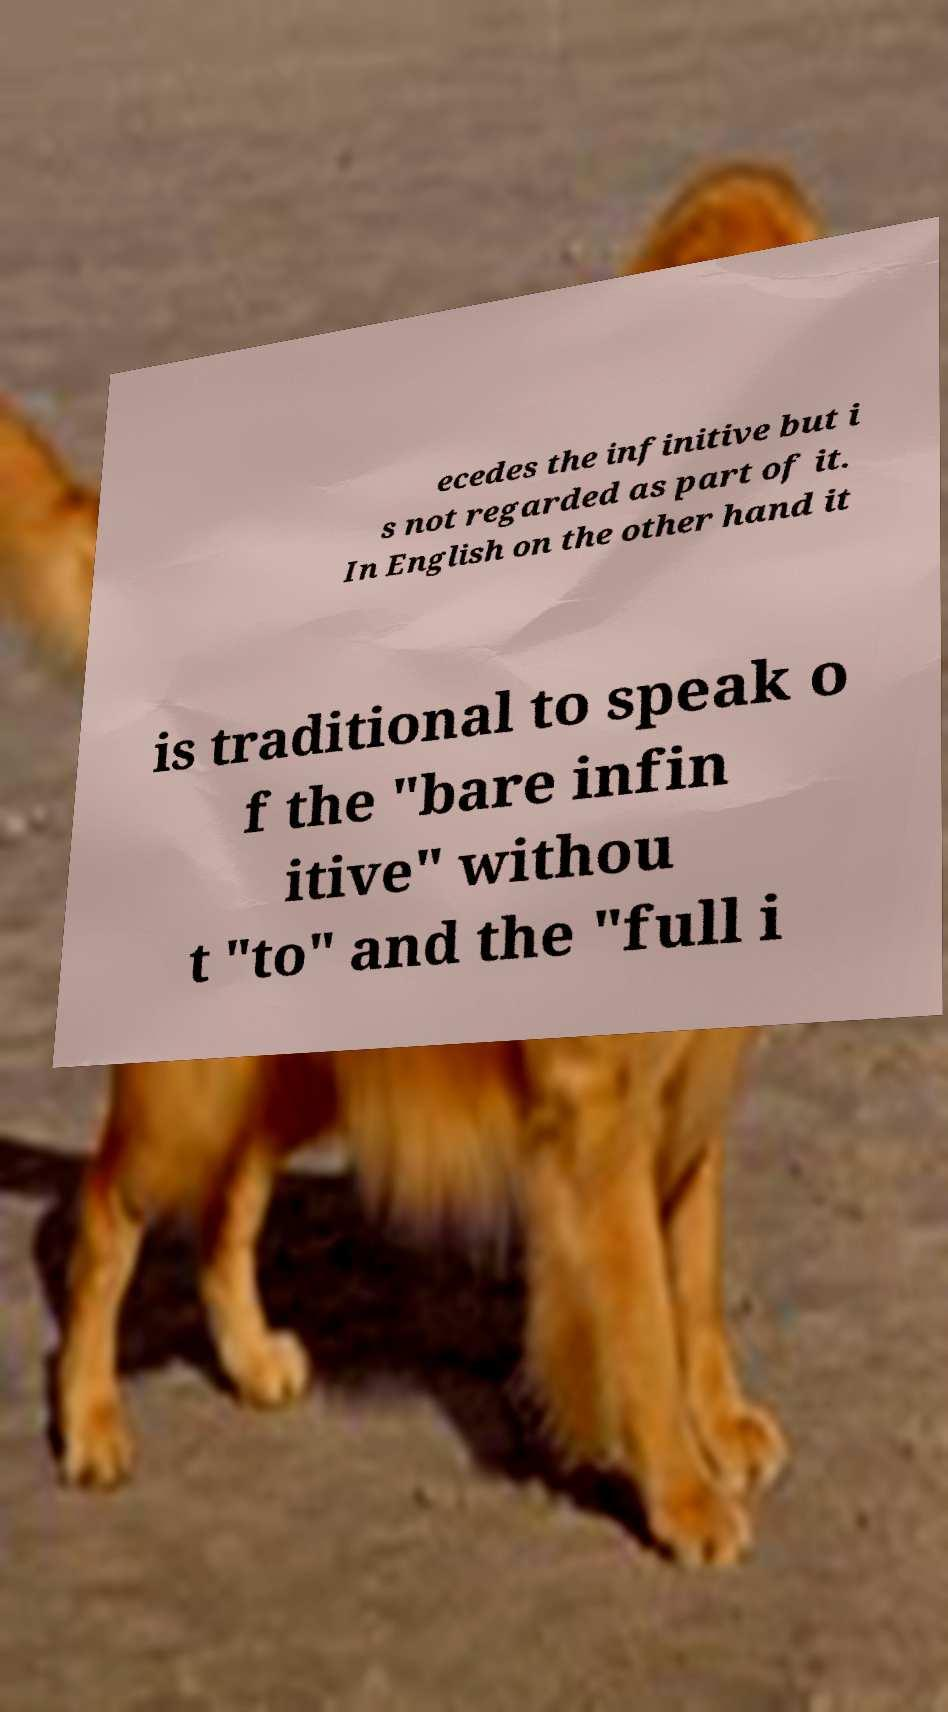There's text embedded in this image that I need extracted. Can you transcribe it verbatim? ecedes the infinitive but i s not regarded as part of it. In English on the other hand it is traditional to speak o f the "bare infin itive" withou t "to" and the "full i 